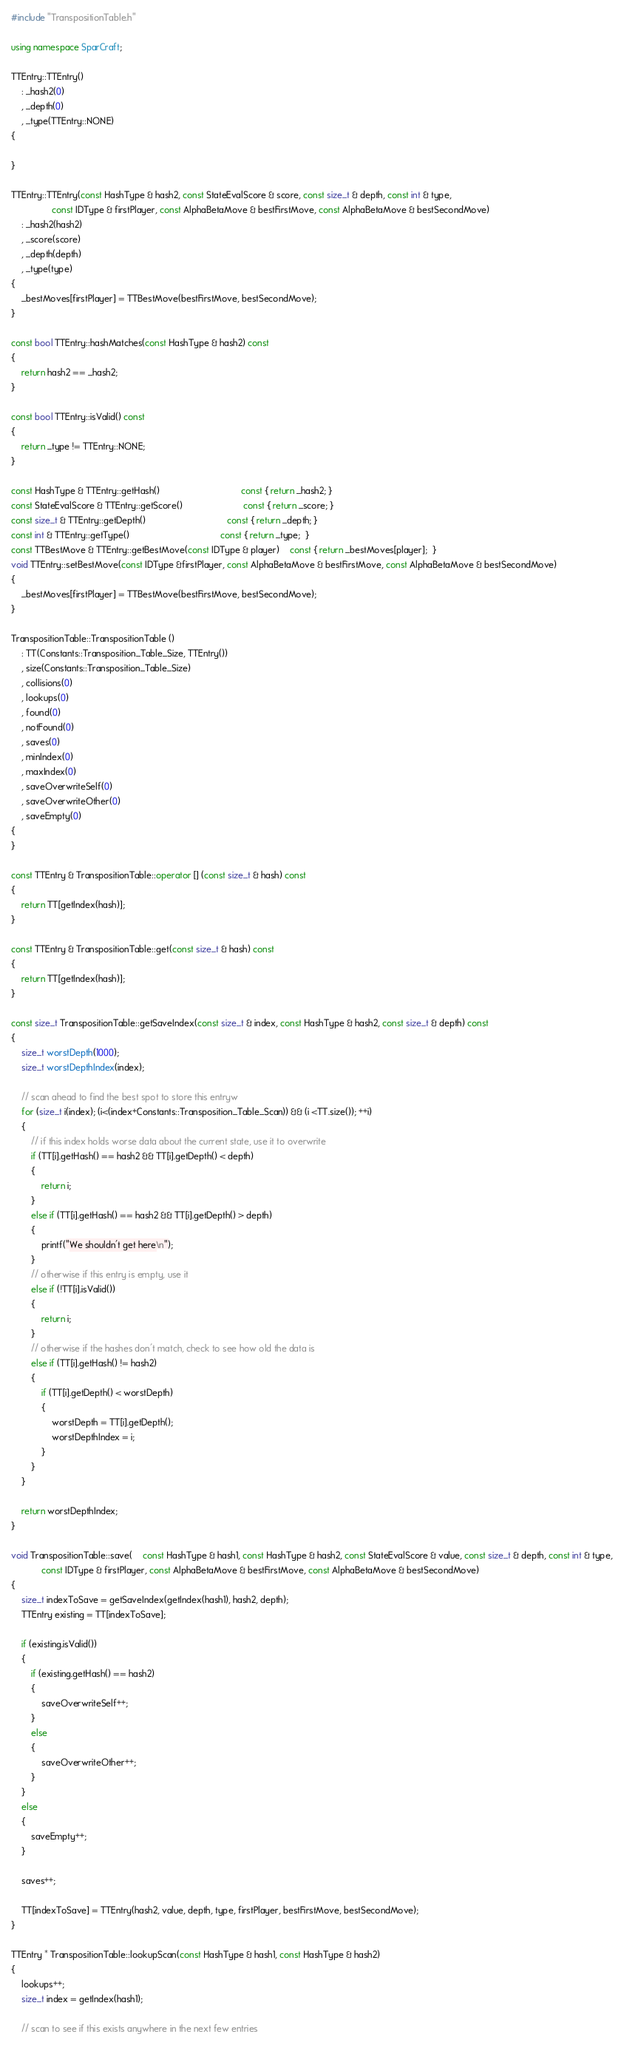Convert code to text. <code><loc_0><loc_0><loc_500><loc_500><_C++_>#include "TranspositionTable.h"

using namespace SparCraft;

TTEntry::TTEntry()
	: _hash2(0)
	, _depth(0)
	, _type(TTEntry::NONE)
{

}

TTEntry::TTEntry(const HashType & hash2, const StateEvalScore & score, const size_t & depth, const int & type, 
				const IDType & firstPlayer, const AlphaBetaMove & bestFirstMove, const AlphaBetaMove & bestSecondMove)
	: _hash2(hash2)
	, _score(score)
	, _depth(depth)
	, _type(type)
{
	_bestMoves[firstPlayer] = TTBestMove(bestFirstMove, bestSecondMove);
}

const bool TTEntry::hashMatches(const HashType & hash2) const
{
	return hash2 == _hash2;
}

const bool TTEntry::isValid() const
{
	return _type != TTEntry::NONE;
}

const HashType & TTEntry::getHash()								const { return _hash2; }
const StateEvalScore & TTEntry::getScore()						const { return _score; }
const size_t & TTEntry::getDepth()								const { return _depth; }
const int & TTEntry::getType()									const { return _type;  }
const TTBestMove & TTEntry::getBestMove(const IDType & player)	const { return _bestMoves[player];  }
void TTEntry::setBestMove(const IDType &firstPlayer, const AlphaBetaMove & bestFirstMove, const AlphaBetaMove & bestSecondMove)
{
	_bestMoves[firstPlayer] = TTBestMove(bestFirstMove, bestSecondMove);
}

TranspositionTable::TranspositionTable () 
	: TT(Constants::Transposition_Table_Size, TTEntry())
	, size(Constants::Transposition_Table_Size)
    , collisions(0)
    , lookups(0)
    , found(0)
    , notFound(0)
	, saves(0)
	, minIndex(0)
	, maxIndex(0)
	, saveOverwriteSelf(0)
	, saveOverwriteOther(0)
	, saveEmpty(0)
{
}
	
const TTEntry & TranspositionTable::operator [] (const size_t & hash) const
{
	return TT[getIndex(hash)];
}

const TTEntry & TranspositionTable::get(const size_t & hash) const
{
	return TT[getIndex(hash)];
}
        
const size_t TranspositionTable::getSaveIndex(const size_t & index, const HashType & hash2, const size_t & depth) const
{
	size_t worstDepth(1000);
	size_t worstDepthIndex(index);

	// scan ahead to find the best spot to store this entryw
	for (size_t i(index); (i<(index+Constants::Transposition_Table_Scan)) && (i <TT.size()); ++i)
	{
		// if this index holds worse data about the current state, use it to overwrite
		if (TT[i].getHash() == hash2 && TT[i].getDepth() < depth)
		{
			return i;
		}
		else if (TT[i].getHash() == hash2 && TT[i].getDepth() > depth)
		{
			printf("We shouldn't get here\n");
		}
		// otherwise if this entry is empty, use it
		else if (!TT[i].isValid())
		{
			return i;
		}
		// otherwise if the hashes don't match, check to see how old the data is
		else if (TT[i].getHash() != hash2)
		{
			if (TT[i].getDepth() < worstDepth)
			{
				worstDepth = TT[i].getDepth();
				worstDepthIndex = i;
			}
		}
	}

	return worstDepthIndex;
}

void TranspositionTable::save(	const HashType & hash1, const HashType & hash2, const StateEvalScore & value, const size_t & depth, const int & type,
			const IDType & firstPlayer, const AlphaBetaMove & bestFirstMove, const AlphaBetaMove & bestSecondMove)
{
	size_t indexToSave = getSaveIndex(getIndex(hash1), hash2, depth);
	TTEntry existing = TT[indexToSave];

	if (existing.isValid())
	{
		if (existing.getHash() == hash2)
		{
			saveOverwriteSelf++;
		}
		else
		{
			saveOverwriteOther++;
		}
	}
	else
	{
		saveEmpty++;
	}

	saves++;
	
	TT[indexToSave] = TTEntry(hash2, value, depth, type, firstPlayer, bestFirstMove, bestSecondMove);
}

TTEntry * TranspositionTable::lookupScan(const HashType & hash1, const HashType & hash2)
{
	lookups++;
	size_t index = getIndex(hash1);

	// scan to see if this exists anywhere in the next few entries</code> 